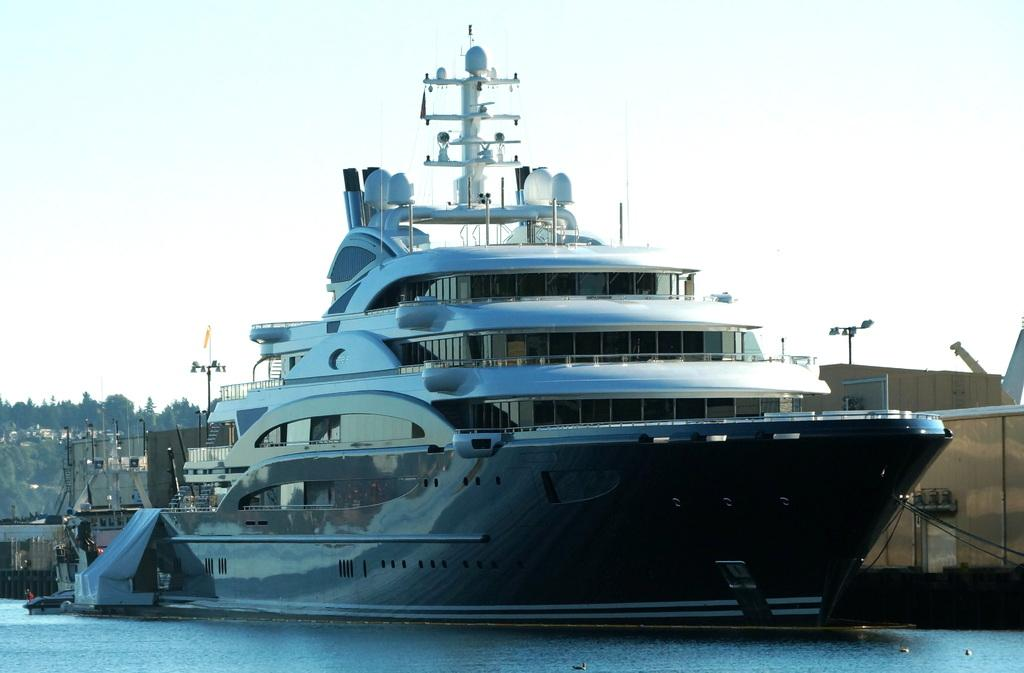What is the main subject of the image? The main subject of the image is a ship. Where is the ship located in the image? The ship is on the water. What can be seen in the background of the image? There are buildings in the background of the image. What type of vegetation is on the left side of the image? There are trees on the left side of the image. What is visible at the top of the image? The sky is visible at the top of the image. What type of cup can be seen in the hand of the person on the ship? There is no person visible on the ship in the image, and therefore no cup can be seen. What type of drink is being consumed by the person on the ship? There is no person visible on the ship in the image, and therefore no drink can be consumed. 